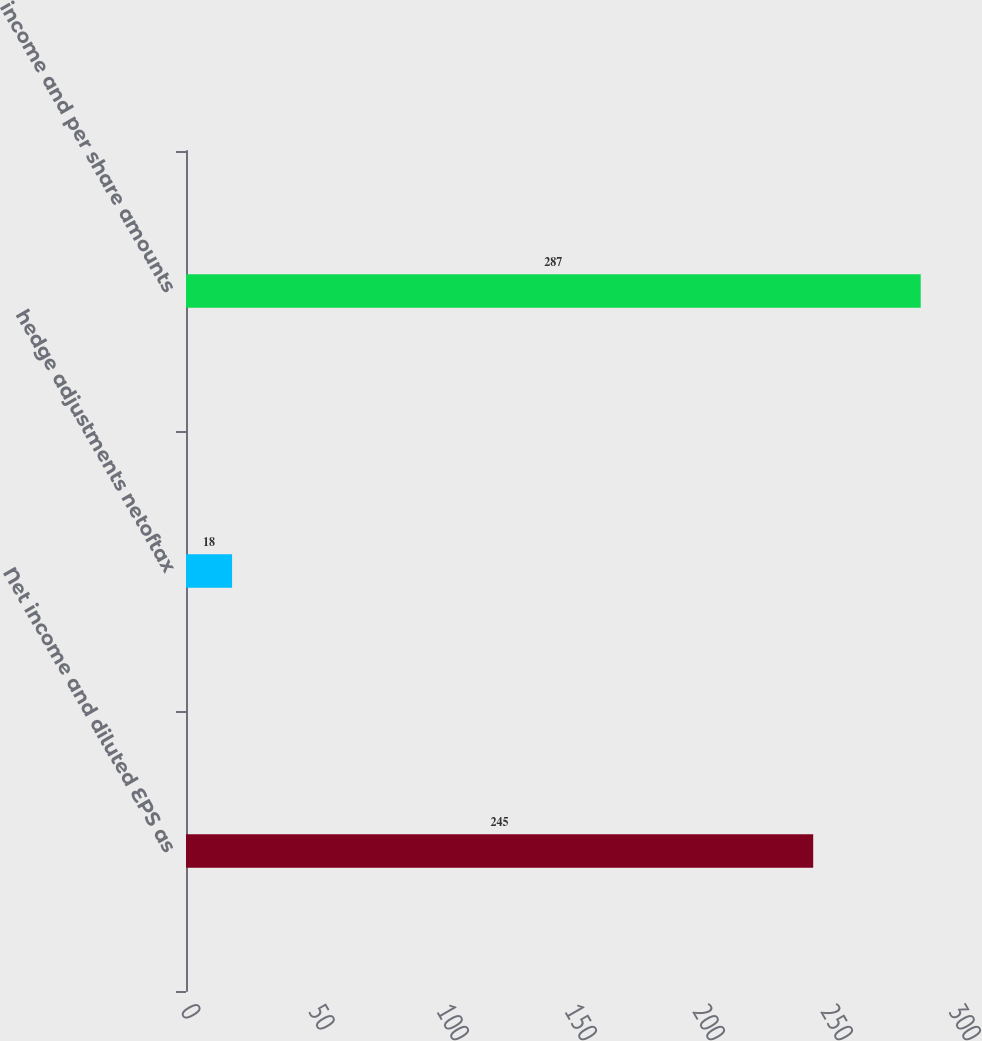Convert chart to OTSL. <chart><loc_0><loc_0><loc_500><loc_500><bar_chart><fcel>Net income and diluted EPS as<fcel>hedge adjustments netoftax<fcel>income and per share amounts<nl><fcel>245<fcel>18<fcel>287<nl></chart> 